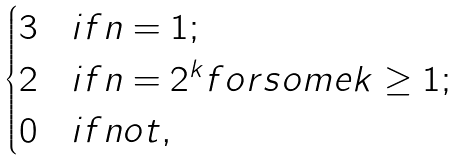<formula> <loc_0><loc_0><loc_500><loc_500>\begin{cases} 3 & i f n = 1 ; \\ 2 & i f n = 2 ^ { k } f o r s o m e k \geq 1 ; \\ 0 & i f n o t , \end{cases}</formula> 